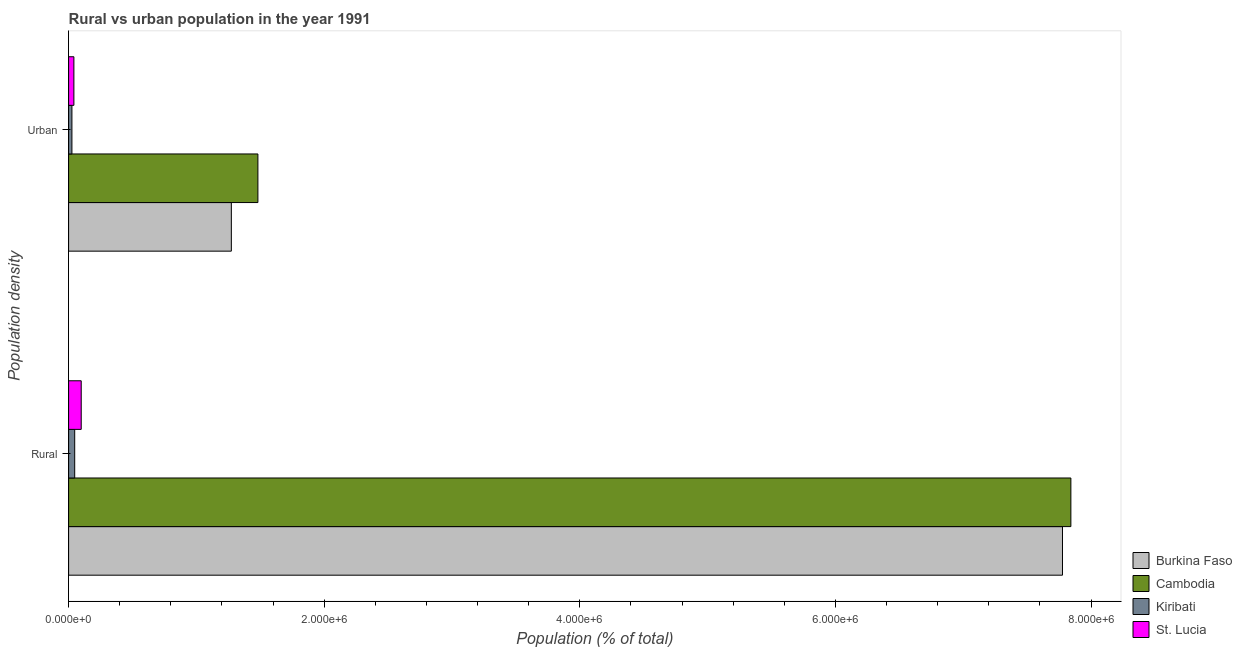How many different coloured bars are there?
Your answer should be very brief. 4. How many bars are there on the 2nd tick from the bottom?
Give a very brief answer. 4. What is the label of the 1st group of bars from the top?
Provide a short and direct response. Urban. What is the urban population density in Cambodia?
Provide a succinct answer. 1.48e+06. Across all countries, what is the maximum rural population density?
Your response must be concise. 7.84e+06. Across all countries, what is the minimum urban population density?
Offer a very short reply. 2.60e+04. In which country was the rural population density maximum?
Offer a terse response. Cambodia. In which country was the urban population density minimum?
Make the answer very short. Kiribati. What is the total urban population density in the graph?
Your answer should be very brief. 2.82e+06. What is the difference between the rural population density in Cambodia and that in St. Lucia?
Your answer should be compact. 7.74e+06. What is the difference between the rural population density in Cambodia and the urban population density in Kiribati?
Ensure brevity in your answer.  7.82e+06. What is the average rural population density per country?
Give a very brief answer. 3.94e+06. What is the difference between the rural population density and urban population density in Kiribati?
Your answer should be compact. 2.17e+04. What is the ratio of the rural population density in Burkina Faso to that in Kiribati?
Offer a terse response. 163.02. In how many countries, is the urban population density greater than the average urban population density taken over all countries?
Offer a terse response. 2. What does the 3rd bar from the top in Rural represents?
Provide a succinct answer. Cambodia. What does the 4th bar from the bottom in Urban represents?
Your answer should be very brief. St. Lucia. How many bars are there?
Offer a very short reply. 8. Are all the bars in the graph horizontal?
Give a very brief answer. Yes. Does the graph contain grids?
Ensure brevity in your answer.  No. Where does the legend appear in the graph?
Offer a terse response. Bottom right. What is the title of the graph?
Offer a very short reply. Rural vs urban population in the year 1991. Does "Turks and Caicos Islands" appear as one of the legend labels in the graph?
Your answer should be compact. No. What is the label or title of the X-axis?
Keep it short and to the point. Population (% of total). What is the label or title of the Y-axis?
Provide a short and direct response. Population density. What is the Population (% of total) in Burkina Faso in Rural?
Your response must be concise. 7.78e+06. What is the Population (% of total) in Cambodia in Rural?
Ensure brevity in your answer.  7.84e+06. What is the Population (% of total) of Kiribati in Rural?
Provide a short and direct response. 4.77e+04. What is the Population (% of total) in St. Lucia in Rural?
Offer a very short reply. 9.87e+04. What is the Population (% of total) in Burkina Faso in Urban?
Provide a succinct answer. 1.27e+06. What is the Population (% of total) of Cambodia in Urban?
Offer a terse response. 1.48e+06. What is the Population (% of total) in Kiribati in Urban?
Ensure brevity in your answer.  2.60e+04. What is the Population (% of total) of St. Lucia in Urban?
Your answer should be very brief. 4.14e+04. Across all Population density, what is the maximum Population (% of total) in Burkina Faso?
Your answer should be compact. 7.78e+06. Across all Population density, what is the maximum Population (% of total) of Cambodia?
Keep it short and to the point. 7.84e+06. Across all Population density, what is the maximum Population (% of total) in Kiribati?
Make the answer very short. 4.77e+04. Across all Population density, what is the maximum Population (% of total) of St. Lucia?
Keep it short and to the point. 9.87e+04. Across all Population density, what is the minimum Population (% of total) in Burkina Faso?
Offer a terse response. 1.27e+06. Across all Population density, what is the minimum Population (% of total) in Cambodia?
Make the answer very short. 1.48e+06. Across all Population density, what is the minimum Population (% of total) of Kiribati?
Your response must be concise. 2.60e+04. Across all Population density, what is the minimum Population (% of total) in St. Lucia?
Offer a terse response. 4.14e+04. What is the total Population (% of total) in Burkina Faso in the graph?
Ensure brevity in your answer.  9.05e+06. What is the total Population (% of total) in Cambodia in the graph?
Your answer should be compact. 9.32e+06. What is the total Population (% of total) of Kiribati in the graph?
Offer a very short reply. 7.37e+04. What is the total Population (% of total) of St. Lucia in the graph?
Your answer should be compact. 1.40e+05. What is the difference between the Population (% of total) in Burkina Faso in Rural and that in Urban?
Make the answer very short. 6.50e+06. What is the difference between the Population (% of total) in Cambodia in Rural and that in Urban?
Make the answer very short. 6.36e+06. What is the difference between the Population (% of total) in Kiribati in Rural and that in Urban?
Ensure brevity in your answer.  2.17e+04. What is the difference between the Population (% of total) of St. Lucia in Rural and that in Urban?
Your answer should be compact. 5.73e+04. What is the difference between the Population (% of total) of Burkina Faso in Rural and the Population (% of total) of Cambodia in Urban?
Keep it short and to the point. 6.30e+06. What is the difference between the Population (% of total) in Burkina Faso in Rural and the Population (% of total) in Kiribati in Urban?
Offer a terse response. 7.75e+06. What is the difference between the Population (% of total) of Burkina Faso in Rural and the Population (% of total) of St. Lucia in Urban?
Make the answer very short. 7.74e+06. What is the difference between the Population (% of total) in Cambodia in Rural and the Population (% of total) in Kiribati in Urban?
Keep it short and to the point. 7.82e+06. What is the difference between the Population (% of total) in Cambodia in Rural and the Population (% of total) in St. Lucia in Urban?
Provide a short and direct response. 7.80e+06. What is the difference between the Population (% of total) in Kiribati in Rural and the Population (% of total) in St. Lucia in Urban?
Ensure brevity in your answer.  6255. What is the average Population (% of total) in Burkina Faso per Population density?
Make the answer very short. 4.53e+06. What is the average Population (% of total) of Cambodia per Population density?
Provide a succinct answer. 4.66e+06. What is the average Population (% of total) in Kiribati per Population density?
Keep it short and to the point. 3.68e+04. What is the average Population (% of total) in St. Lucia per Population density?
Give a very brief answer. 7.01e+04. What is the difference between the Population (% of total) in Burkina Faso and Population (% of total) in Cambodia in Rural?
Your answer should be compact. -6.56e+04. What is the difference between the Population (% of total) of Burkina Faso and Population (% of total) of Kiribati in Rural?
Make the answer very short. 7.73e+06. What is the difference between the Population (% of total) in Burkina Faso and Population (% of total) in St. Lucia in Rural?
Your answer should be compact. 7.68e+06. What is the difference between the Population (% of total) of Cambodia and Population (% of total) of Kiribati in Rural?
Provide a succinct answer. 7.79e+06. What is the difference between the Population (% of total) in Cambodia and Population (% of total) in St. Lucia in Rural?
Your answer should be very brief. 7.74e+06. What is the difference between the Population (% of total) in Kiribati and Population (% of total) in St. Lucia in Rural?
Keep it short and to the point. -5.10e+04. What is the difference between the Population (% of total) of Burkina Faso and Population (% of total) of Cambodia in Urban?
Offer a terse response. -2.08e+05. What is the difference between the Population (% of total) in Burkina Faso and Population (% of total) in Kiribati in Urban?
Your answer should be compact. 1.25e+06. What is the difference between the Population (% of total) in Burkina Faso and Population (% of total) in St. Lucia in Urban?
Provide a short and direct response. 1.23e+06. What is the difference between the Population (% of total) in Cambodia and Population (% of total) in Kiribati in Urban?
Keep it short and to the point. 1.46e+06. What is the difference between the Population (% of total) in Cambodia and Population (% of total) in St. Lucia in Urban?
Your answer should be compact. 1.44e+06. What is the difference between the Population (% of total) in Kiribati and Population (% of total) in St. Lucia in Urban?
Your answer should be compact. -1.55e+04. What is the ratio of the Population (% of total) in Burkina Faso in Rural to that in Urban?
Provide a short and direct response. 6.11. What is the ratio of the Population (% of total) of Cambodia in Rural to that in Urban?
Give a very brief answer. 5.29. What is the ratio of the Population (% of total) of Kiribati in Rural to that in Urban?
Your answer should be compact. 1.84. What is the ratio of the Population (% of total) of St. Lucia in Rural to that in Urban?
Offer a terse response. 2.38. What is the difference between the highest and the second highest Population (% of total) in Burkina Faso?
Offer a very short reply. 6.50e+06. What is the difference between the highest and the second highest Population (% of total) in Cambodia?
Provide a succinct answer. 6.36e+06. What is the difference between the highest and the second highest Population (% of total) of Kiribati?
Ensure brevity in your answer.  2.17e+04. What is the difference between the highest and the second highest Population (% of total) of St. Lucia?
Provide a succinct answer. 5.73e+04. What is the difference between the highest and the lowest Population (% of total) in Burkina Faso?
Your answer should be very brief. 6.50e+06. What is the difference between the highest and the lowest Population (% of total) in Cambodia?
Your response must be concise. 6.36e+06. What is the difference between the highest and the lowest Population (% of total) in Kiribati?
Offer a very short reply. 2.17e+04. What is the difference between the highest and the lowest Population (% of total) of St. Lucia?
Keep it short and to the point. 5.73e+04. 